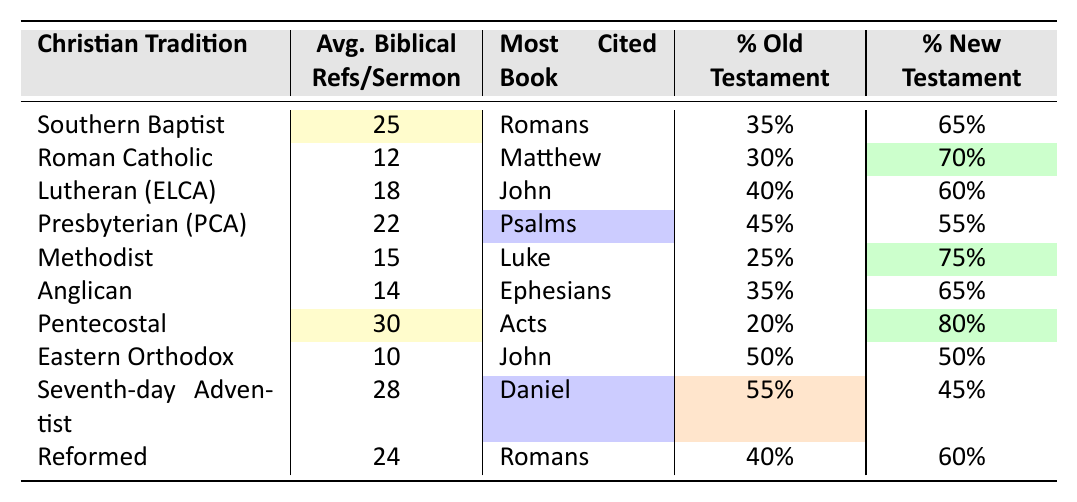What is the average number of biblical references per sermon in the Southern Baptist tradition? According to the table, the Southern Baptist tradition has an average of 25 biblical references per sermon.
Answer: 25 Which Christian tradition has the most biblical references per sermon? The Pentecostal tradition has the highest average of 30 biblical references per sermon, as seen in the table.
Answer: Pentecostal What is the most cited book in the Lutheran (ELCA) tradition? The table indicates that the most cited book in the Lutheran (ELCA) tradition is John.
Answer: John Is the percentage of Old Testament references higher in the Presbyterian (PCA) tradition than in the Roman Catholic tradition? The Presbyterian (PCA) tradition has 45% Old Testament references, while the Roman Catholic tradition has 30%. Since 45% is greater than 30%, the statement is true.
Answer: Yes How many more biblical references, on average, do Pentecostal sermons have compared to Eastern Orthodox sermons? The average for Pentecostal sermons is 30, and for Eastern Orthodox sermons, it is 10. The difference is 30 - 10 = 20.
Answer: 20 In which Christian tradition is the percentage of New Testament references lowest? By examining the percentages, the Eastern Orthodox tradition has 50% New Testament references, which is the lowest percentage compared to the others.
Answer: Eastern Orthodox Which tradition cites the book of Daniel most frequently? The table shows that the Seventh-day Adventist tradition cites the book of Daniel most frequently, with it being the most cited book in their sermons.
Answer: Seventh-day Adventist If we were to calculate the average number of biblical references per sermon for all the traditions listed, would it exceed 20? First, we sum the average biblical references: 25 + 12 + 18 + 22 + 15 + 14 + 30 + 10 + 28 + 24 =  204. There are 10 traditions, so the average is 204 / 10 = 20.4, which exceeds 20.
Answer: Yes What percentage of biblical references in the sermons of the Methodist tradition comes from the New Testament? The table indicates that 75% of biblical references in the Methodist tradition come from the New Testament.
Answer: 75% How does the percentage of Old Testament references in Seventh-day Adventist sermons compare to that in Pentecostal sermons? The Seventh-day Adventist tradition has 55% Old Testament references, while the Pentecostal tradition has 20%. Therefore, Seventh-day Adventists reference the Old Testament more than Pentecostals.
Answer: Higher in Seventh-day Adventist 